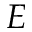<formula> <loc_0><loc_0><loc_500><loc_500>E</formula> 